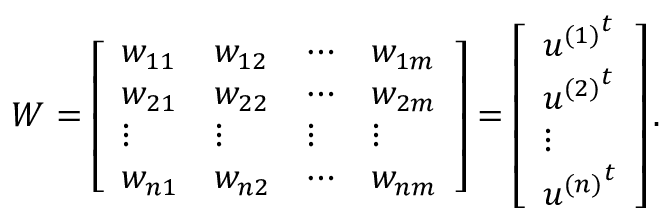Convert formula to latex. <formula><loc_0><loc_0><loc_500><loc_500>W = \left [ \begin{array} { l l l l } { w _ { 1 1 } } & { w _ { 1 2 } } & { \cdots } & { w _ { 1 m } } \\ { w _ { 2 1 } } & { w _ { 2 2 } } & { \cdots } & { w _ { 2 m } } \\ { \vdots } & { \vdots } & { \vdots } & { \vdots } \\ { w _ { n 1 } } & { w _ { n 2 } } & { \cdots } & { w _ { n m } } \end{array} \right ] = \left [ \begin{array} { l } { { u ^ { ( 1 ) } } ^ { t } } \\ { { u ^ { ( 2 ) } } ^ { t } } \\ { \vdots } \\ { { u ^ { ( n ) } } ^ { t } } \end{array} \right ] .</formula> 